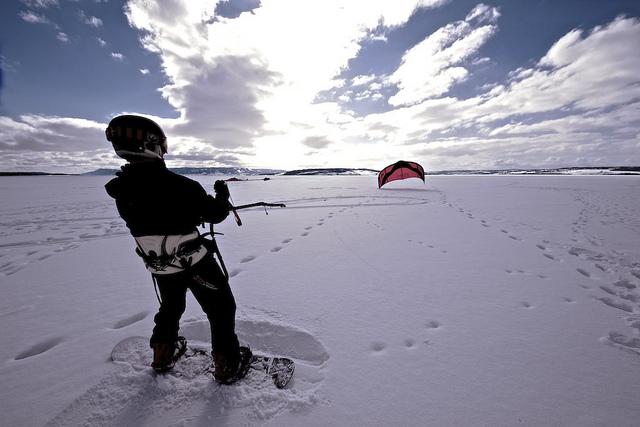Is this person flying a kite?
Give a very brief answer. Yes. Is this person standing in sand?
Write a very short answer. No. What is covering the ground?
Short answer required. Snow. What is the man holding onto?
Short answer required. Kite. 